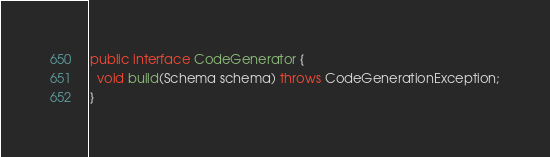Convert code to text. <code><loc_0><loc_0><loc_500><loc_500><_Java_>public interface CodeGenerator {
  void build(Schema schema) throws CodeGenerationException;
}
</code> 